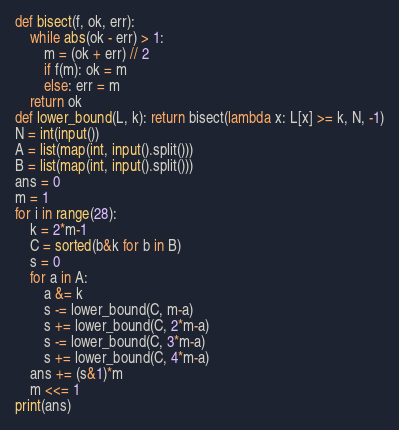<code> <loc_0><loc_0><loc_500><loc_500><_Python_>def bisect(f, ok, err):
    while abs(ok - err) > 1:
        m = (ok + err) // 2
        if f(m): ok = m
        else: err = m
    return ok
def lower_bound(L, k): return bisect(lambda x: L[x] >= k, N, -1)
N = int(input())
A = list(map(int, input().split()))
B = list(map(int, input().split()))
ans = 0
m = 1
for i in range(28):
    k = 2*m-1
    C = sorted(b&k for b in B)
    s = 0
    for a in A:
        a &= k
        s -= lower_bound(C, m-a)
        s += lower_bound(C, 2*m-a)
        s -= lower_bound(C, 3*m-a)
        s += lower_bound(C, 4*m-a)
    ans += (s&1)*m
    m <<= 1
print(ans)</code> 